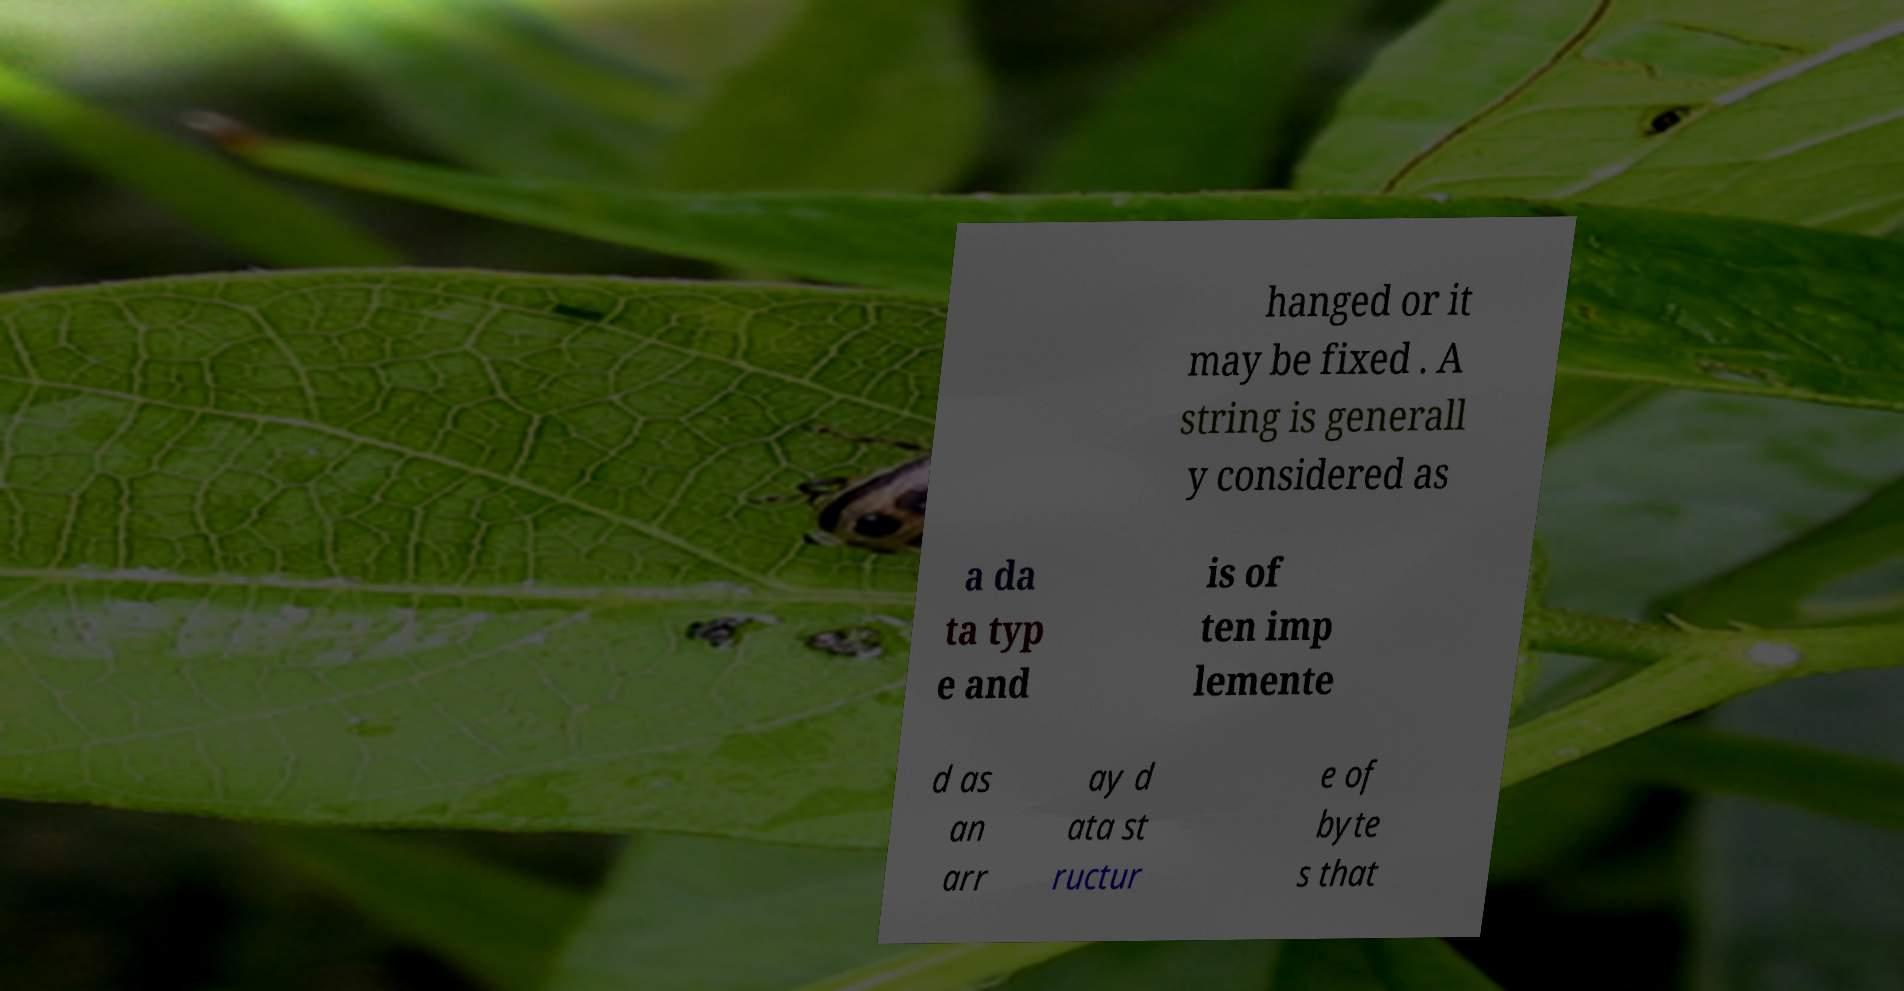What messages or text are displayed in this image? I need them in a readable, typed format. hanged or it may be fixed . A string is generall y considered as a da ta typ e and is of ten imp lemente d as an arr ay d ata st ructur e of byte s that 